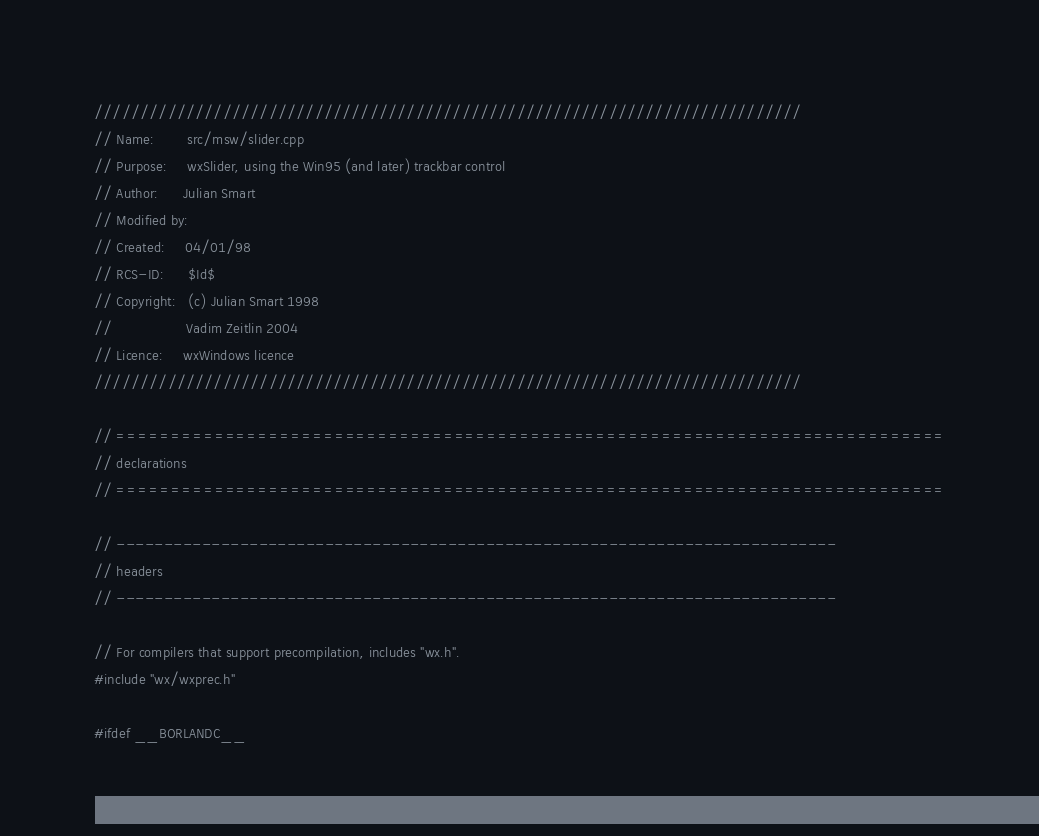Convert code to text. <code><loc_0><loc_0><loc_500><loc_500><_C++_>/////////////////////////////////////////////////////////////////////////////
// Name:        src/msw/slider.cpp
// Purpose:     wxSlider, using the Win95 (and later) trackbar control
// Author:      Julian Smart
// Modified by:
// Created:     04/01/98
// RCS-ID:      $Id$
// Copyright:   (c) Julian Smart 1998
//                  Vadim Zeitlin 2004
// Licence:     wxWindows licence
/////////////////////////////////////////////////////////////////////////////

// ============================================================================
// declarations
// ============================================================================

// ----------------------------------------------------------------------------
// headers
// ----------------------------------------------------------------------------

// For compilers that support precompilation, includes "wx.h".
#include "wx/wxprec.h"

#ifdef __BORLANDC__</code> 